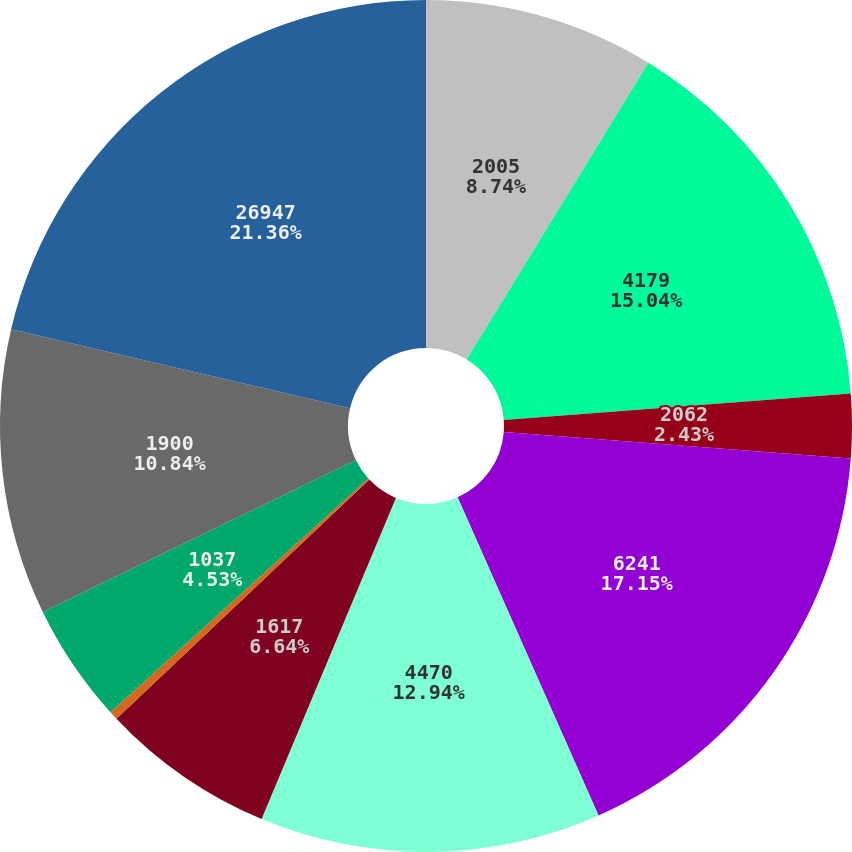Convert chart to OTSL. <chart><loc_0><loc_0><loc_500><loc_500><pie_chart><fcel>2005<fcel>4179<fcel>2062<fcel>6241<fcel>4470<fcel>1617<fcel>580<fcel>1037<fcel>1900<fcel>26947<nl><fcel>8.74%<fcel>15.04%<fcel>2.43%<fcel>17.15%<fcel>12.94%<fcel>6.64%<fcel>0.33%<fcel>4.53%<fcel>10.84%<fcel>21.35%<nl></chart> 